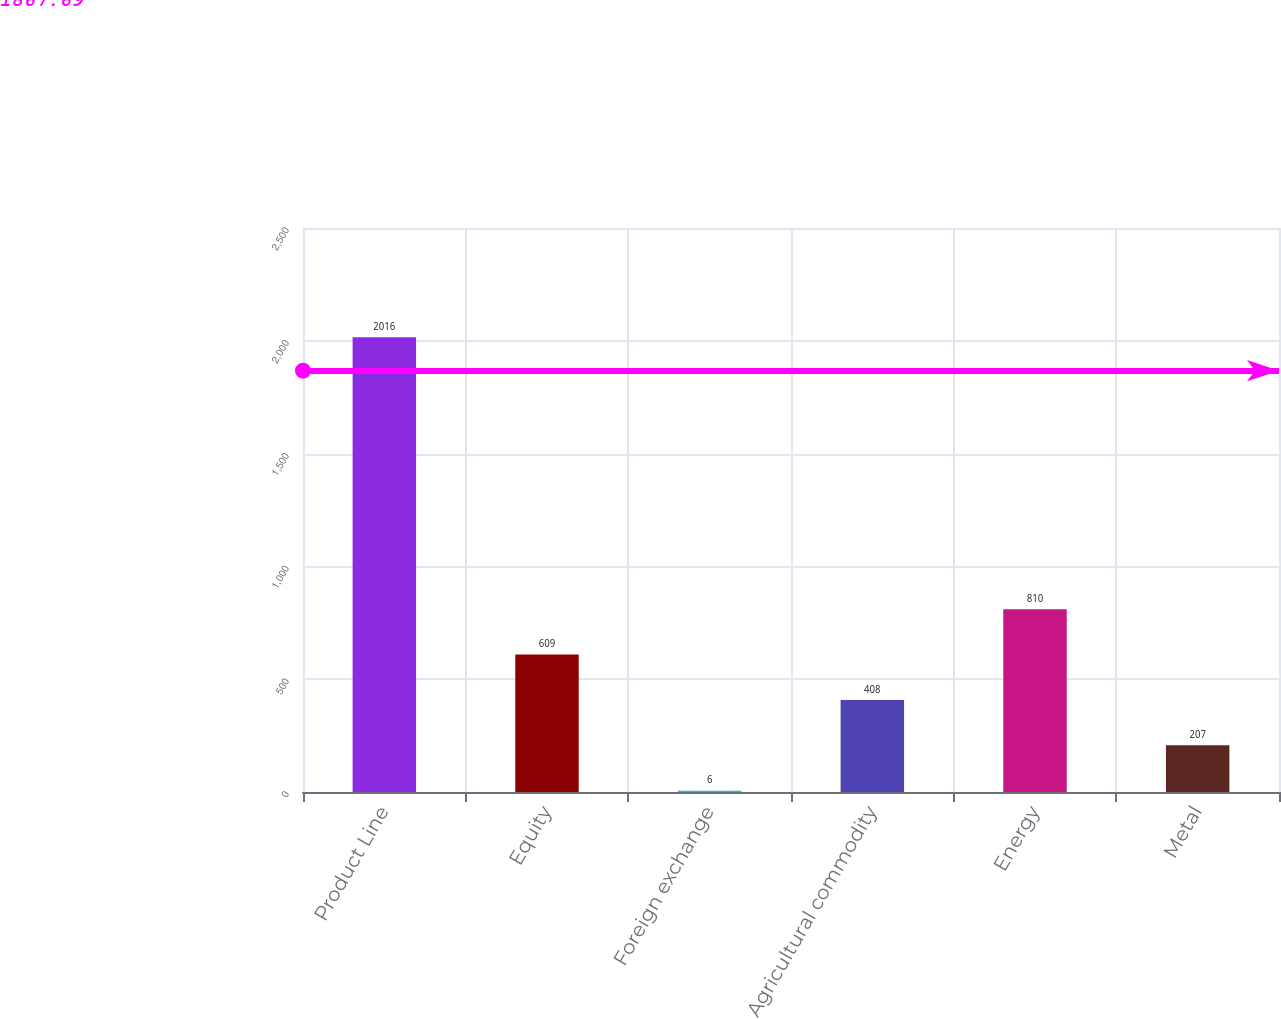Convert chart to OTSL. <chart><loc_0><loc_0><loc_500><loc_500><bar_chart><fcel>Product Line<fcel>Equity<fcel>Foreign exchange<fcel>Agricultural commodity<fcel>Energy<fcel>Metal<nl><fcel>2016<fcel>609<fcel>6<fcel>408<fcel>810<fcel>207<nl></chart> 